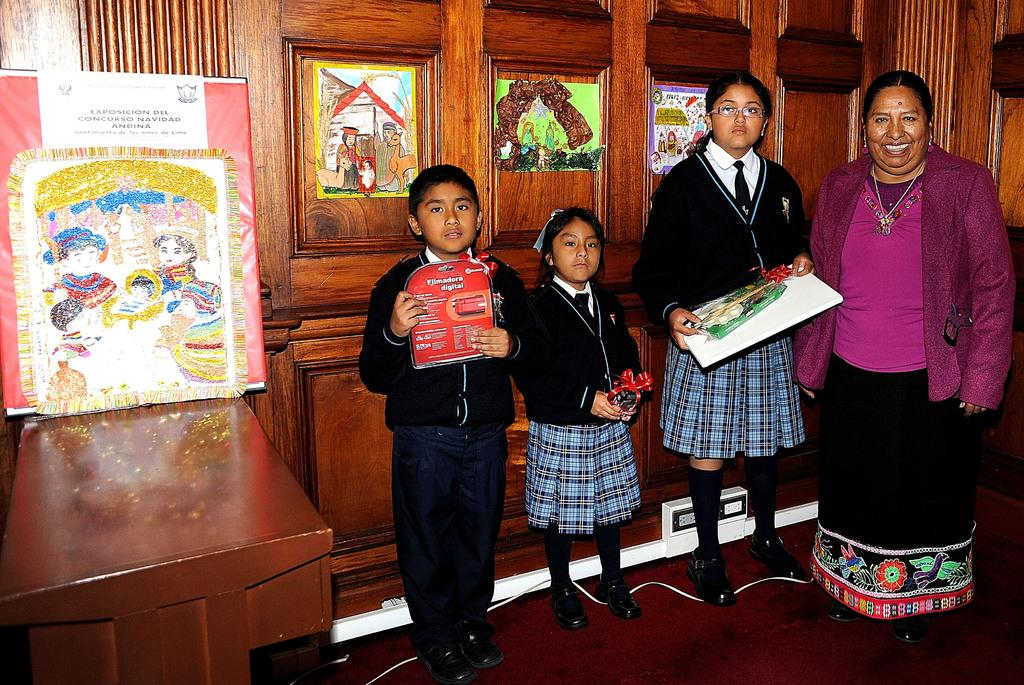How many people can be seen in the image? There are many persons standing on the floor in the image. What can be seen in the background of the image? There are drawings and a door in the background. What type of structure is visible in the background? There is a wall in the background. What type of animals can be seen at the zoo attraction in the image? There is no zoo or attraction present in the image; it features a group of people standing on the floor with drawings and a door in the background. 